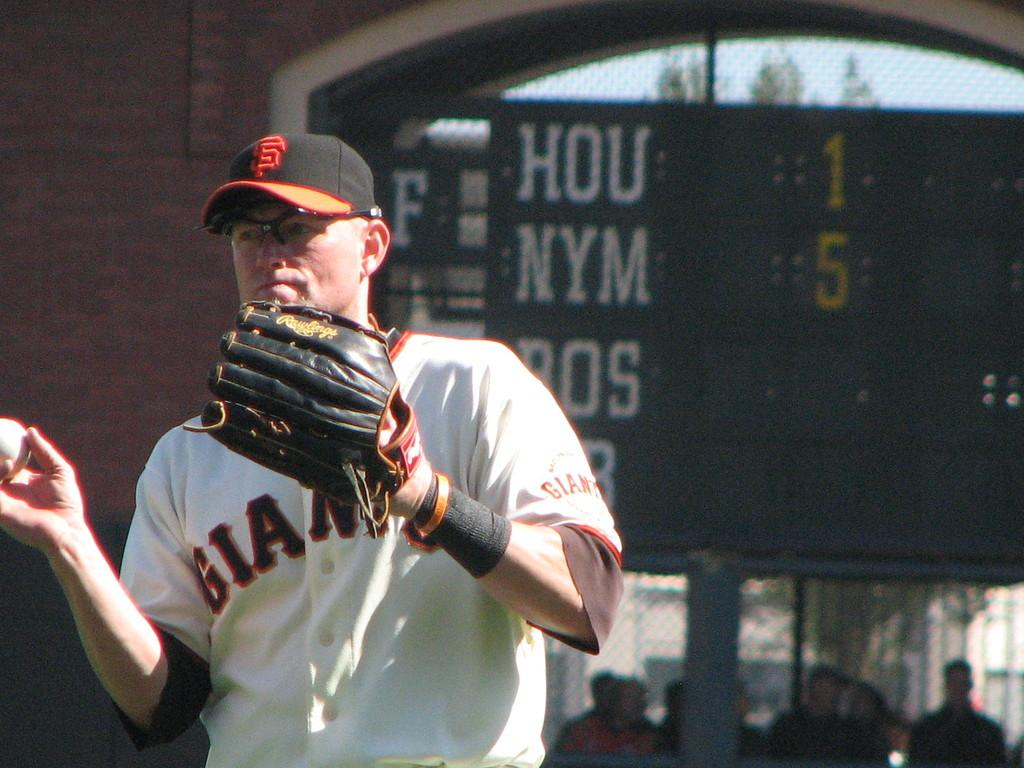<image>
Summarize the visual content of the image. a person wearing a Giants jersey that is outside 